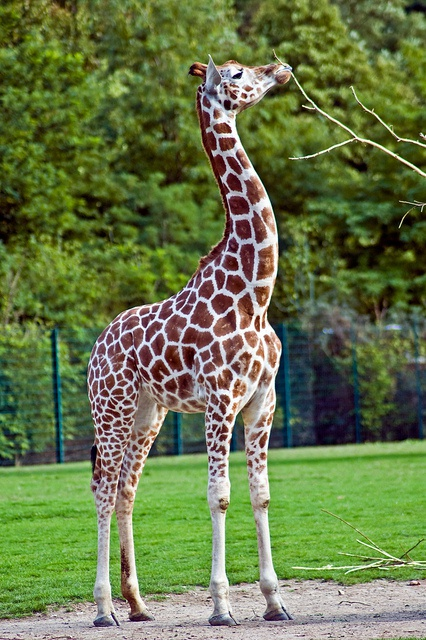Describe the objects in this image and their specific colors. I can see a giraffe in darkgreen, lightgray, maroon, darkgray, and gray tones in this image. 